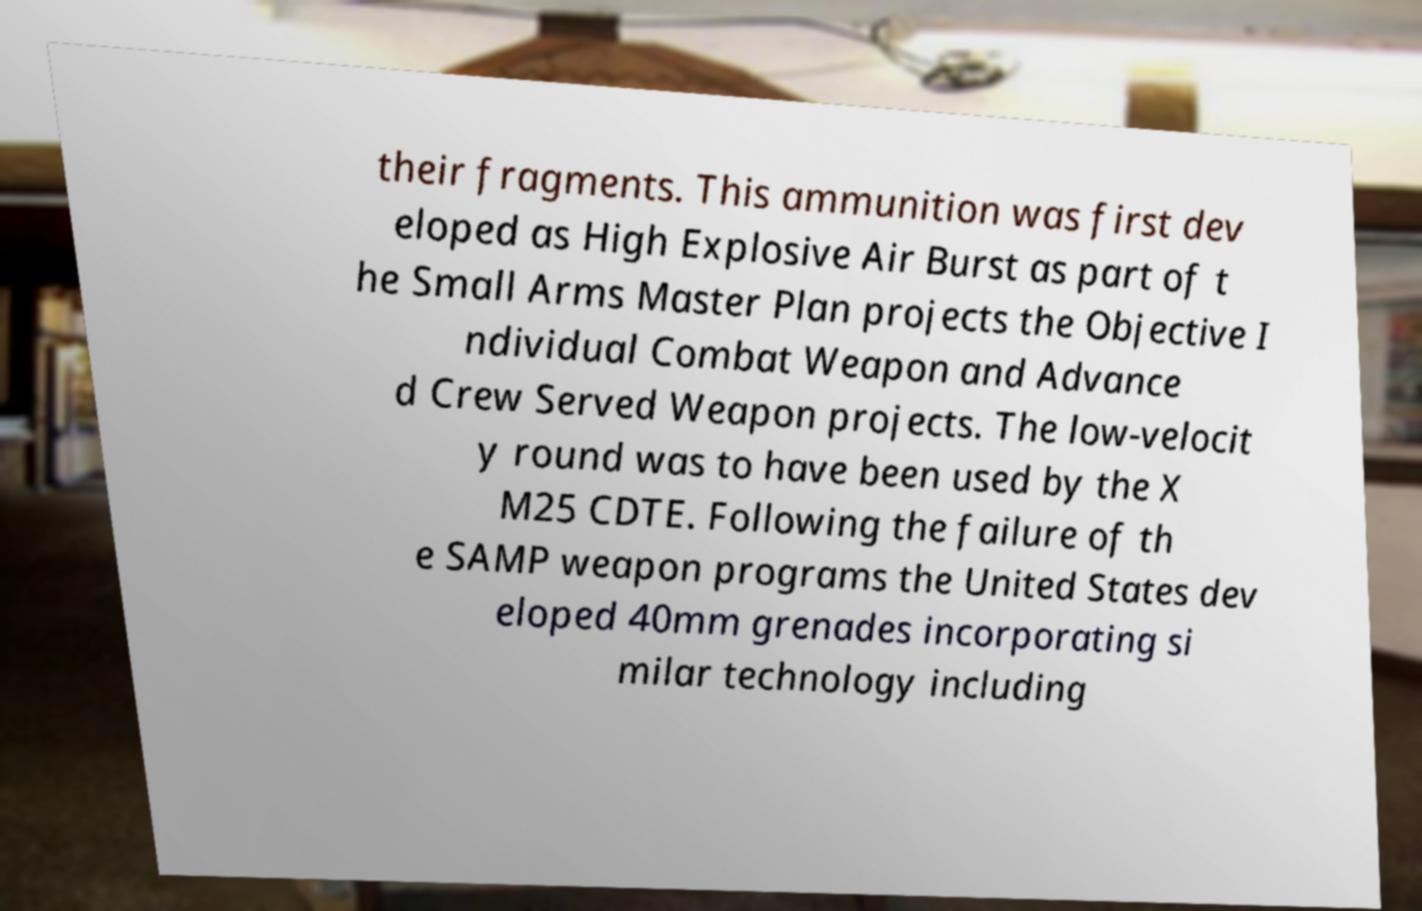I need the written content from this picture converted into text. Can you do that? their fragments. This ammunition was first dev eloped as High Explosive Air Burst as part of t he Small Arms Master Plan projects the Objective I ndividual Combat Weapon and Advance d Crew Served Weapon projects. The low-velocit y round was to have been used by the X M25 CDTE. Following the failure of th e SAMP weapon programs the United States dev eloped 40mm grenades incorporating si milar technology including 